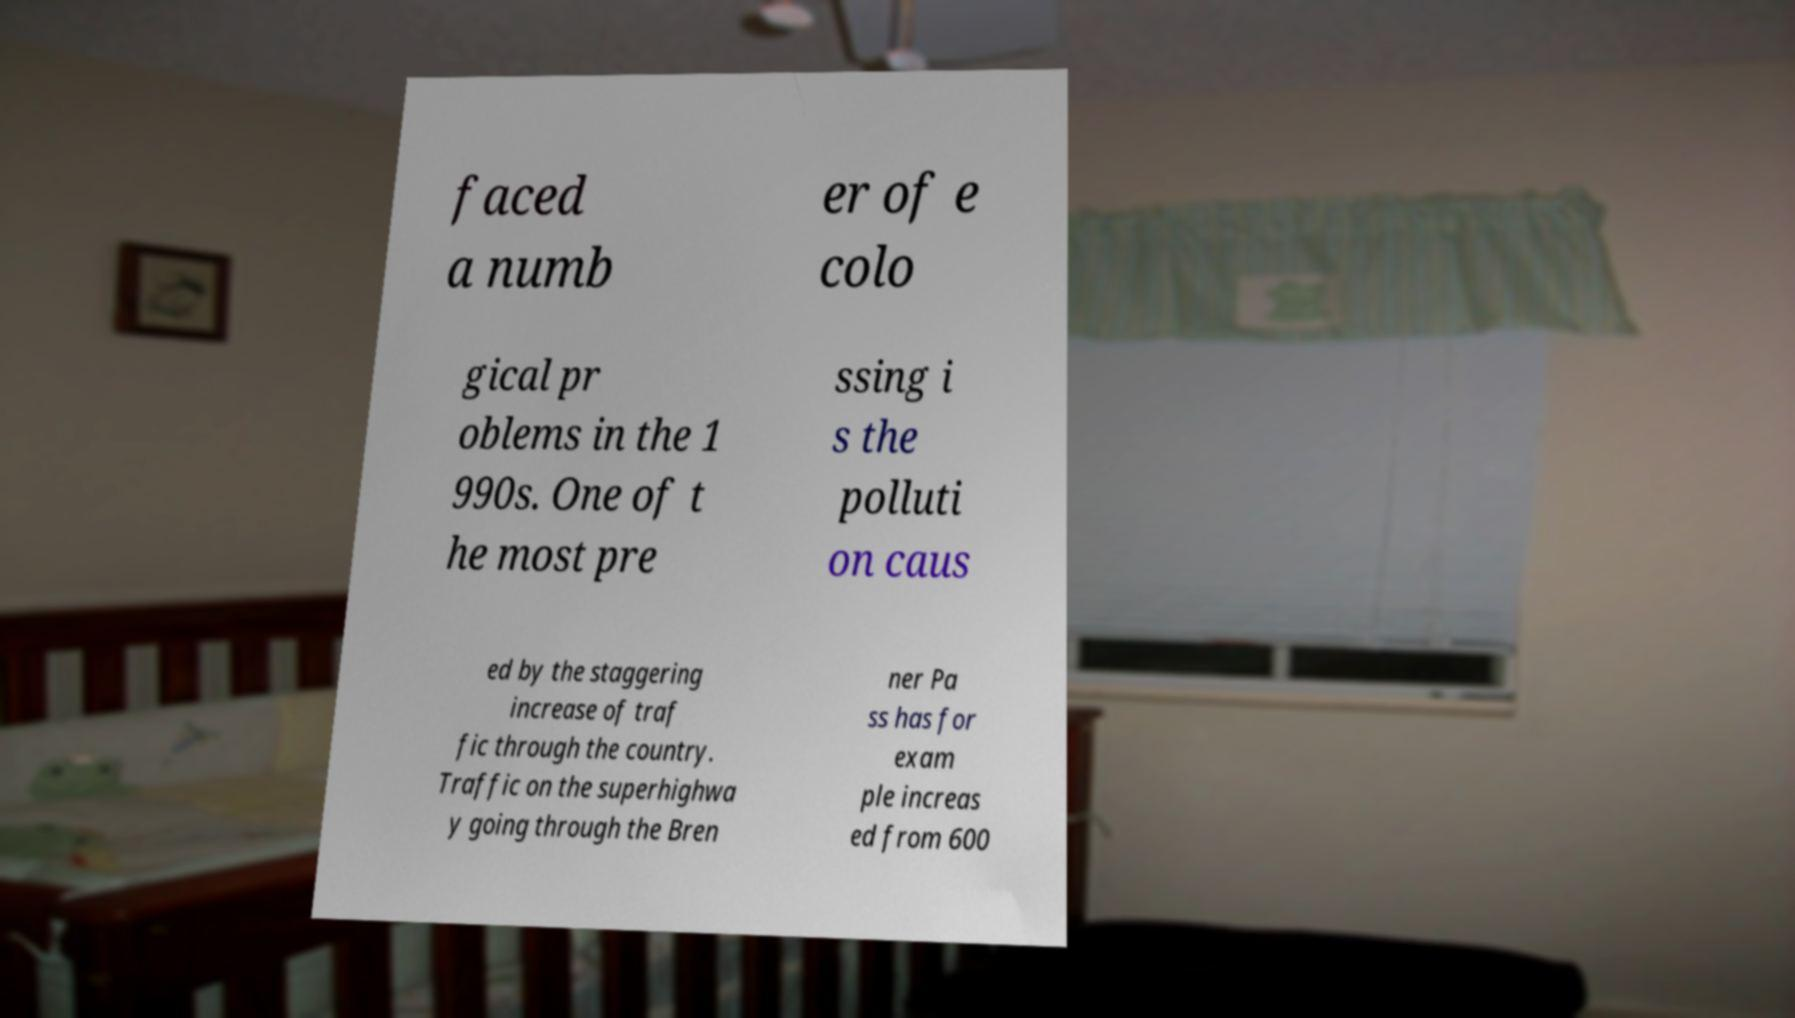Could you extract and type out the text from this image? faced a numb er of e colo gical pr oblems in the 1 990s. One of t he most pre ssing i s the polluti on caus ed by the staggering increase of traf fic through the country. Traffic on the superhighwa y going through the Bren ner Pa ss has for exam ple increas ed from 600 